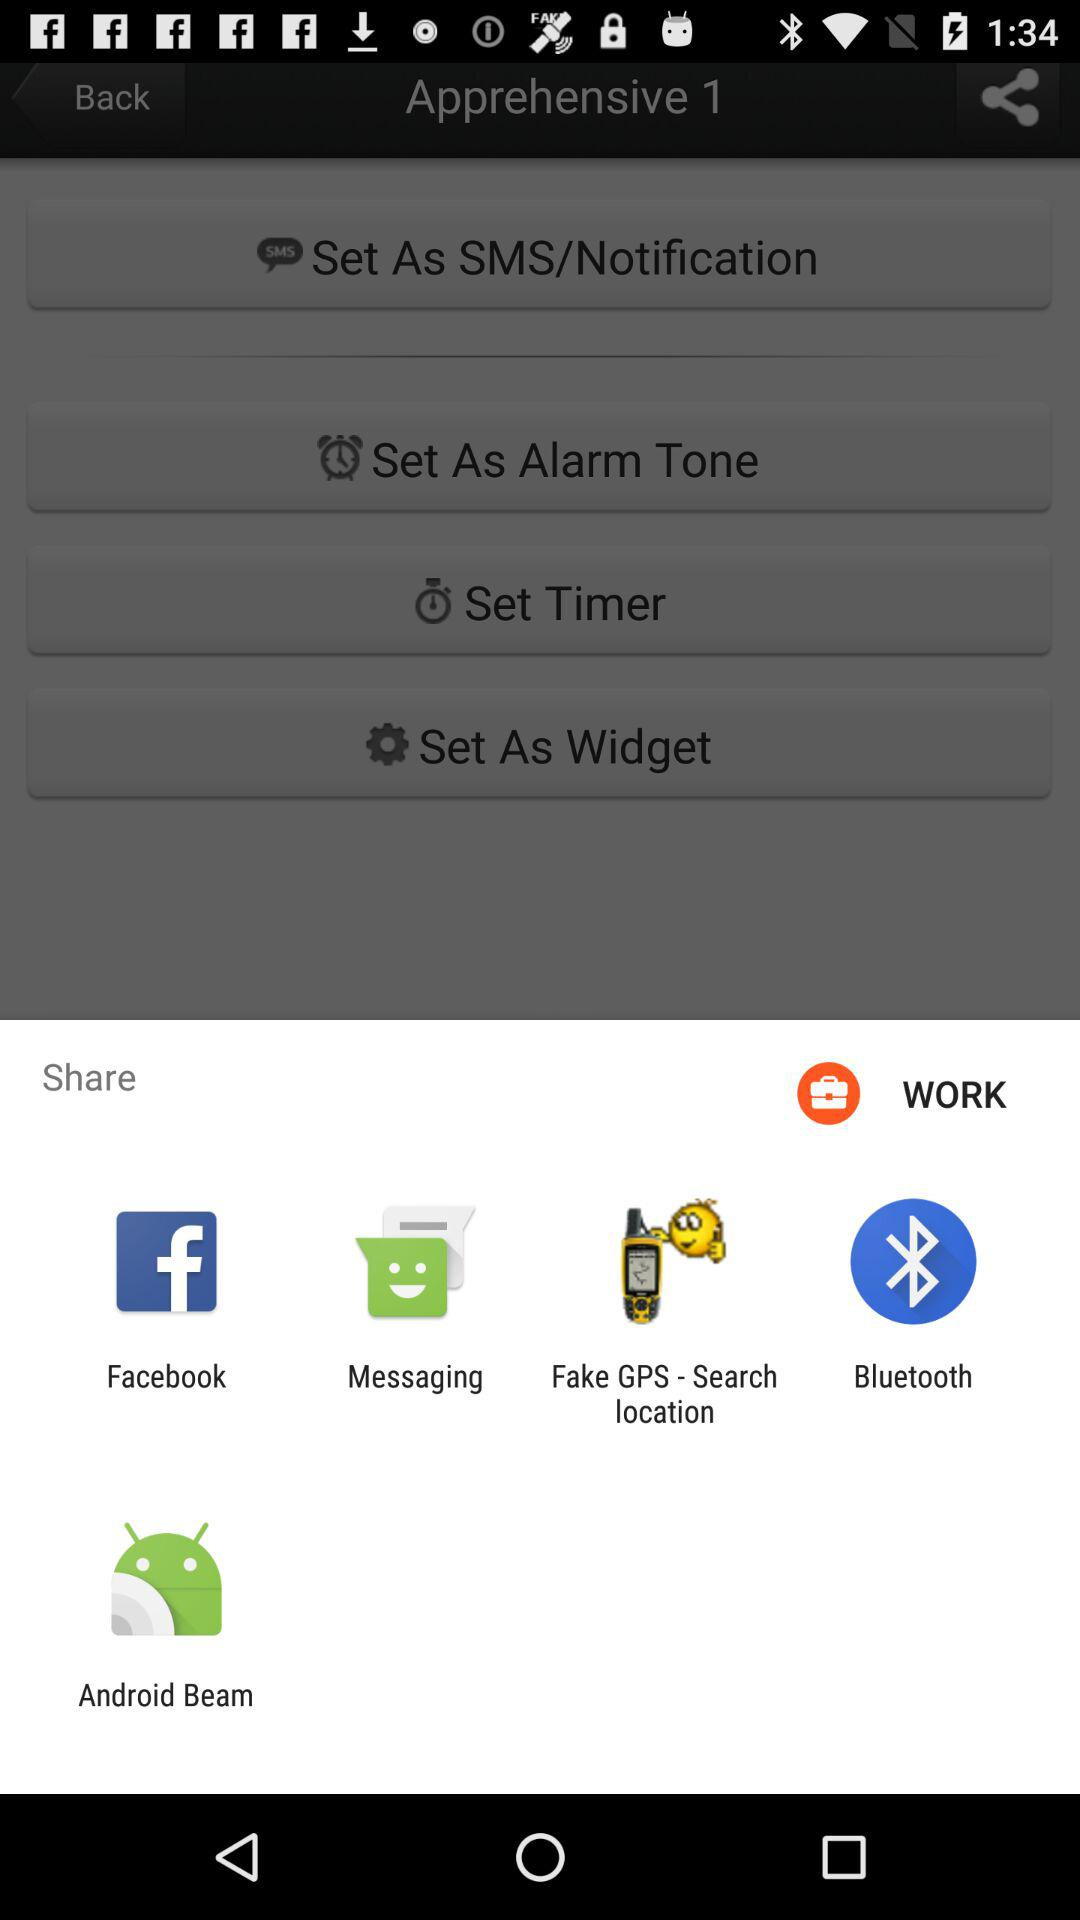Through which applications can we share? You can share through "Facebook", "Messaging", "Fake GPS - Search location", "Bluetooth" and "Android Beam". 